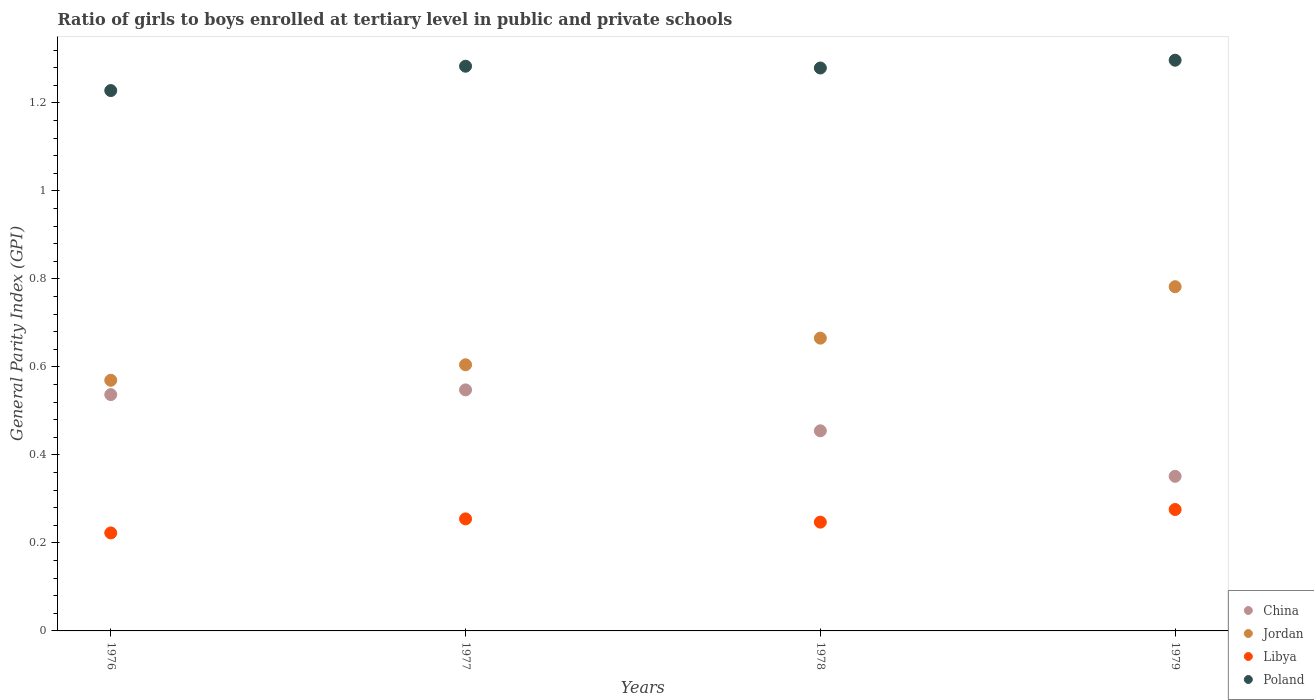How many different coloured dotlines are there?
Your response must be concise. 4. Is the number of dotlines equal to the number of legend labels?
Provide a short and direct response. Yes. What is the general parity index in China in 1977?
Keep it short and to the point. 0.55. Across all years, what is the maximum general parity index in Jordan?
Offer a terse response. 0.78. Across all years, what is the minimum general parity index in China?
Provide a succinct answer. 0.35. In which year was the general parity index in Poland minimum?
Make the answer very short. 1976. What is the total general parity index in China in the graph?
Give a very brief answer. 1.89. What is the difference between the general parity index in Libya in 1976 and that in 1977?
Keep it short and to the point. -0.03. What is the difference between the general parity index in Poland in 1979 and the general parity index in China in 1978?
Make the answer very short. 0.84. What is the average general parity index in Poland per year?
Offer a terse response. 1.27. In the year 1979, what is the difference between the general parity index in Poland and general parity index in Jordan?
Provide a succinct answer. 0.51. In how many years, is the general parity index in Poland greater than 0.12?
Ensure brevity in your answer.  4. What is the ratio of the general parity index in Libya in 1976 to that in 1977?
Make the answer very short. 0.87. Is the difference between the general parity index in Poland in 1977 and 1978 greater than the difference between the general parity index in Jordan in 1977 and 1978?
Offer a very short reply. Yes. What is the difference between the highest and the second highest general parity index in Poland?
Keep it short and to the point. 0.01. What is the difference between the highest and the lowest general parity index in Poland?
Provide a succinct answer. 0.07. Is the sum of the general parity index in Poland in 1977 and 1978 greater than the maximum general parity index in China across all years?
Your answer should be compact. Yes. Is it the case that in every year, the sum of the general parity index in Libya and general parity index in Jordan  is greater than the sum of general parity index in China and general parity index in Poland?
Ensure brevity in your answer.  No. Is the general parity index in China strictly less than the general parity index in Libya over the years?
Offer a very short reply. No. How many dotlines are there?
Provide a succinct answer. 4. Are the values on the major ticks of Y-axis written in scientific E-notation?
Provide a succinct answer. No. Does the graph contain grids?
Keep it short and to the point. No. Where does the legend appear in the graph?
Offer a very short reply. Bottom right. How are the legend labels stacked?
Make the answer very short. Vertical. What is the title of the graph?
Provide a short and direct response. Ratio of girls to boys enrolled at tertiary level in public and private schools. What is the label or title of the Y-axis?
Provide a succinct answer. General Parity Index (GPI). What is the General Parity Index (GPI) of China in 1976?
Provide a short and direct response. 0.54. What is the General Parity Index (GPI) in Jordan in 1976?
Offer a very short reply. 0.57. What is the General Parity Index (GPI) of Libya in 1976?
Offer a very short reply. 0.22. What is the General Parity Index (GPI) of Poland in 1976?
Give a very brief answer. 1.23. What is the General Parity Index (GPI) in China in 1977?
Make the answer very short. 0.55. What is the General Parity Index (GPI) in Jordan in 1977?
Offer a terse response. 0.6. What is the General Parity Index (GPI) in Libya in 1977?
Your answer should be compact. 0.25. What is the General Parity Index (GPI) of Poland in 1977?
Ensure brevity in your answer.  1.28. What is the General Parity Index (GPI) of China in 1978?
Make the answer very short. 0.45. What is the General Parity Index (GPI) of Jordan in 1978?
Offer a very short reply. 0.67. What is the General Parity Index (GPI) of Libya in 1978?
Provide a succinct answer. 0.25. What is the General Parity Index (GPI) of Poland in 1978?
Make the answer very short. 1.28. What is the General Parity Index (GPI) in China in 1979?
Your answer should be very brief. 0.35. What is the General Parity Index (GPI) of Jordan in 1979?
Provide a succinct answer. 0.78. What is the General Parity Index (GPI) in Libya in 1979?
Your answer should be compact. 0.28. What is the General Parity Index (GPI) in Poland in 1979?
Your response must be concise. 1.3. Across all years, what is the maximum General Parity Index (GPI) in China?
Your answer should be very brief. 0.55. Across all years, what is the maximum General Parity Index (GPI) in Jordan?
Give a very brief answer. 0.78. Across all years, what is the maximum General Parity Index (GPI) of Libya?
Provide a succinct answer. 0.28. Across all years, what is the maximum General Parity Index (GPI) of Poland?
Offer a terse response. 1.3. Across all years, what is the minimum General Parity Index (GPI) in China?
Make the answer very short. 0.35. Across all years, what is the minimum General Parity Index (GPI) in Jordan?
Give a very brief answer. 0.57. Across all years, what is the minimum General Parity Index (GPI) of Libya?
Provide a succinct answer. 0.22. Across all years, what is the minimum General Parity Index (GPI) of Poland?
Provide a short and direct response. 1.23. What is the total General Parity Index (GPI) in China in the graph?
Provide a short and direct response. 1.89. What is the total General Parity Index (GPI) in Jordan in the graph?
Keep it short and to the point. 2.62. What is the total General Parity Index (GPI) in Libya in the graph?
Offer a terse response. 1. What is the total General Parity Index (GPI) of Poland in the graph?
Provide a succinct answer. 5.09. What is the difference between the General Parity Index (GPI) of China in 1976 and that in 1977?
Your answer should be compact. -0.01. What is the difference between the General Parity Index (GPI) in Jordan in 1976 and that in 1977?
Give a very brief answer. -0.04. What is the difference between the General Parity Index (GPI) in Libya in 1976 and that in 1977?
Offer a terse response. -0.03. What is the difference between the General Parity Index (GPI) of Poland in 1976 and that in 1977?
Give a very brief answer. -0.06. What is the difference between the General Parity Index (GPI) in China in 1976 and that in 1978?
Offer a very short reply. 0.08. What is the difference between the General Parity Index (GPI) of Jordan in 1976 and that in 1978?
Offer a very short reply. -0.1. What is the difference between the General Parity Index (GPI) in Libya in 1976 and that in 1978?
Your response must be concise. -0.02. What is the difference between the General Parity Index (GPI) of Poland in 1976 and that in 1978?
Your response must be concise. -0.05. What is the difference between the General Parity Index (GPI) of China in 1976 and that in 1979?
Make the answer very short. 0.19. What is the difference between the General Parity Index (GPI) of Jordan in 1976 and that in 1979?
Provide a short and direct response. -0.21. What is the difference between the General Parity Index (GPI) of Libya in 1976 and that in 1979?
Give a very brief answer. -0.05. What is the difference between the General Parity Index (GPI) of Poland in 1976 and that in 1979?
Offer a terse response. -0.07. What is the difference between the General Parity Index (GPI) of China in 1977 and that in 1978?
Your answer should be compact. 0.09. What is the difference between the General Parity Index (GPI) in Jordan in 1977 and that in 1978?
Your response must be concise. -0.06. What is the difference between the General Parity Index (GPI) in Libya in 1977 and that in 1978?
Give a very brief answer. 0.01. What is the difference between the General Parity Index (GPI) in Poland in 1977 and that in 1978?
Keep it short and to the point. 0. What is the difference between the General Parity Index (GPI) in China in 1977 and that in 1979?
Provide a succinct answer. 0.2. What is the difference between the General Parity Index (GPI) of Jordan in 1977 and that in 1979?
Provide a short and direct response. -0.18. What is the difference between the General Parity Index (GPI) of Libya in 1977 and that in 1979?
Offer a terse response. -0.02. What is the difference between the General Parity Index (GPI) of Poland in 1977 and that in 1979?
Offer a terse response. -0.01. What is the difference between the General Parity Index (GPI) in China in 1978 and that in 1979?
Offer a very short reply. 0.1. What is the difference between the General Parity Index (GPI) in Jordan in 1978 and that in 1979?
Ensure brevity in your answer.  -0.12. What is the difference between the General Parity Index (GPI) in Libya in 1978 and that in 1979?
Provide a succinct answer. -0.03. What is the difference between the General Parity Index (GPI) of Poland in 1978 and that in 1979?
Keep it short and to the point. -0.02. What is the difference between the General Parity Index (GPI) of China in 1976 and the General Parity Index (GPI) of Jordan in 1977?
Your response must be concise. -0.07. What is the difference between the General Parity Index (GPI) of China in 1976 and the General Parity Index (GPI) of Libya in 1977?
Your answer should be compact. 0.28. What is the difference between the General Parity Index (GPI) in China in 1976 and the General Parity Index (GPI) in Poland in 1977?
Your answer should be compact. -0.75. What is the difference between the General Parity Index (GPI) of Jordan in 1976 and the General Parity Index (GPI) of Libya in 1977?
Provide a succinct answer. 0.32. What is the difference between the General Parity Index (GPI) in Jordan in 1976 and the General Parity Index (GPI) in Poland in 1977?
Your answer should be compact. -0.71. What is the difference between the General Parity Index (GPI) in Libya in 1976 and the General Parity Index (GPI) in Poland in 1977?
Offer a terse response. -1.06. What is the difference between the General Parity Index (GPI) of China in 1976 and the General Parity Index (GPI) of Jordan in 1978?
Give a very brief answer. -0.13. What is the difference between the General Parity Index (GPI) in China in 1976 and the General Parity Index (GPI) in Libya in 1978?
Offer a very short reply. 0.29. What is the difference between the General Parity Index (GPI) in China in 1976 and the General Parity Index (GPI) in Poland in 1978?
Give a very brief answer. -0.74. What is the difference between the General Parity Index (GPI) of Jordan in 1976 and the General Parity Index (GPI) of Libya in 1978?
Offer a very short reply. 0.32. What is the difference between the General Parity Index (GPI) in Jordan in 1976 and the General Parity Index (GPI) in Poland in 1978?
Provide a short and direct response. -0.71. What is the difference between the General Parity Index (GPI) in Libya in 1976 and the General Parity Index (GPI) in Poland in 1978?
Your answer should be compact. -1.06. What is the difference between the General Parity Index (GPI) in China in 1976 and the General Parity Index (GPI) in Jordan in 1979?
Your answer should be compact. -0.25. What is the difference between the General Parity Index (GPI) in China in 1976 and the General Parity Index (GPI) in Libya in 1979?
Make the answer very short. 0.26. What is the difference between the General Parity Index (GPI) in China in 1976 and the General Parity Index (GPI) in Poland in 1979?
Offer a terse response. -0.76. What is the difference between the General Parity Index (GPI) of Jordan in 1976 and the General Parity Index (GPI) of Libya in 1979?
Your response must be concise. 0.29. What is the difference between the General Parity Index (GPI) in Jordan in 1976 and the General Parity Index (GPI) in Poland in 1979?
Offer a terse response. -0.73. What is the difference between the General Parity Index (GPI) of Libya in 1976 and the General Parity Index (GPI) of Poland in 1979?
Offer a terse response. -1.07. What is the difference between the General Parity Index (GPI) in China in 1977 and the General Parity Index (GPI) in Jordan in 1978?
Give a very brief answer. -0.12. What is the difference between the General Parity Index (GPI) of China in 1977 and the General Parity Index (GPI) of Libya in 1978?
Give a very brief answer. 0.3. What is the difference between the General Parity Index (GPI) in China in 1977 and the General Parity Index (GPI) in Poland in 1978?
Make the answer very short. -0.73. What is the difference between the General Parity Index (GPI) in Jordan in 1977 and the General Parity Index (GPI) in Libya in 1978?
Your response must be concise. 0.36. What is the difference between the General Parity Index (GPI) in Jordan in 1977 and the General Parity Index (GPI) in Poland in 1978?
Provide a succinct answer. -0.67. What is the difference between the General Parity Index (GPI) in Libya in 1977 and the General Parity Index (GPI) in Poland in 1978?
Provide a succinct answer. -1.02. What is the difference between the General Parity Index (GPI) of China in 1977 and the General Parity Index (GPI) of Jordan in 1979?
Give a very brief answer. -0.23. What is the difference between the General Parity Index (GPI) in China in 1977 and the General Parity Index (GPI) in Libya in 1979?
Offer a very short reply. 0.27. What is the difference between the General Parity Index (GPI) in China in 1977 and the General Parity Index (GPI) in Poland in 1979?
Offer a very short reply. -0.75. What is the difference between the General Parity Index (GPI) of Jordan in 1977 and the General Parity Index (GPI) of Libya in 1979?
Your response must be concise. 0.33. What is the difference between the General Parity Index (GPI) of Jordan in 1977 and the General Parity Index (GPI) of Poland in 1979?
Offer a very short reply. -0.69. What is the difference between the General Parity Index (GPI) in Libya in 1977 and the General Parity Index (GPI) in Poland in 1979?
Your answer should be compact. -1.04. What is the difference between the General Parity Index (GPI) of China in 1978 and the General Parity Index (GPI) of Jordan in 1979?
Ensure brevity in your answer.  -0.33. What is the difference between the General Parity Index (GPI) of China in 1978 and the General Parity Index (GPI) of Libya in 1979?
Provide a succinct answer. 0.18. What is the difference between the General Parity Index (GPI) of China in 1978 and the General Parity Index (GPI) of Poland in 1979?
Your response must be concise. -0.84. What is the difference between the General Parity Index (GPI) of Jordan in 1978 and the General Parity Index (GPI) of Libya in 1979?
Ensure brevity in your answer.  0.39. What is the difference between the General Parity Index (GPI) of Jordan in 1978 and the General Parity Index (GPI) of Poland in 1979?
Provide a succinct answer. -0.63. What is the difference between the General Parity Index (GPI) of Libya in 1978 and the General Parity Index (GPI) of Poland in 1979?
Ensure brevity in your answer.  -1.05. What is the average General Parity Index (GPI) in China per year?
Provide a short and direct response. 0.47. What is the average General Parity Index (GPI) of Jordan per year?
Offer a very short reply. 0.66. What is the average General Parity Index (GPI) in Libya per year?
Offer a terse response. 0.25. What is the average General Parity Index (GPI) in Poland per year?
Give a very brief answer. 1.27. In the year 1976, what is the difference between the General Parity Index (GPI) of China and General Parity Index (GPI) of Jordan?
Offer a very short reply. -0.03. In the year 1976, what is the difference between the General Parity Index (GPI) of China and General Parity Index (GPI) of Libya?
Keep it short and to the point. 0.31. In the year 1976, what is the difference between the General Parity Index (GPI) of China and General Parity Index (GPI) of Poland?
Your answer should be very brief. -0.69. In the year 1976, what is the difference between the General Parity Index (GPI) of Jordan and General Parity Index (GPI) of Libya?
Ensure brevity in your answer.  0.35. In the year 1976, what is the difference between the General Parity Index (GPI) of Jordan and General Parity Index (GPI) of Poland?
Provide a short and direct response. -0.66. In the year 1976, what is the difference between the General Parity Index (GPI) of Libya and General Parity Index (GPI) of Poland?
Provide a short and direct response. -1.01. In the year 1977, what is the difference between the General Parity Index (GPI) of China and General Parity Index (GPI) of Jordan?
Offer a terse response. -0.06. In the year 1977, what is the difference between the General Parity Index (GPI) in China and General Parity Index (GPI) in Libya?
Your response must be concise. 0.29. In the year 1977, what is the difference between the General Parity Index (GPI) of China and General Parity Index (GPI) of Poland?
Your answer should be very brief. -0.74. In the year 1977, what is the difference between the General Parity Index (GPI) of Jordan and General Parity Index (GPI) of Libya?
Offer a very short reply. 0.35. In the year 1977, what is the difference between the General Parity Index (GPI) in Jordan and General Parity Index (GPI) in Poland?
Your answer should be very brief. -0.68. In the year 1977, what is the difference between the General Parity Index (GPI) of Libya and General Parity Index (GPI) of Poland?
Your answer should be very brief. -1.03. In the year 1978, what is the difference between the General Parity Index (GPI) in China and General Parity Index (GPI) in Jordan?
Ensure brevity in your answer.  -0.21. In the year 1978, what is the difference between the General Parity Index (GPI) of China and General Parity Index (GPI) of Libya?
Your answer should be very brief. 0.21. In the year 1978, what is the difference between the General Parity Index (GPI) in China and General Parity Index (GPI) in Poland?
Your answer should be compact. -0.82. In the year 1978, what is the difference between the General Parity Index (GPI) in Jordan and General Parity Index (GPI) in Libya?
Your answer should be compact. 0.42. In the year 1978, what is the difference between the General Parity Index (GPI) of Jordan and General Parity Index (GPI) of Poland?
Give a very brief answer. -0.61. In the year 1978, what is the difference between the General Parity Index (GPI) in Libya and General Parity Index (GPI) in Poland?
Provide a succinct answer. -1.03. In the year 1979, what is the difference between the General Parity Index (GPI) of China and General Parity Index (GPI) of Jordan?
Give a very brief answer. -0.43. In the year 1979, what is the difference between the General Parity Index (GPI) in China and General Parity Index (GPI) in Libya?
Keep it short and to the point. 0.08. In the year 1979, what is the difference between the General Parity Index (GPI) in China and General Parity Index (GPI) in Poland?
Provide a short and direct response. -0.95. In the year 1979, what is the difference between the General Parity Index (GPI) in Jordan and General Parity Index (GPI) in Libya?
Give a very brief answer. 0.51. In the year 1979, what is the difference between the General Parity Index (GPI) of Jordan and General Parity Index (GPI) of Poland?
Offer a terse response. -0.51. In the year 1979, what is the difference between the General Parity Index (GPI) of Libya and General Parity Index (GPI) of Poland?
Provide a succinct answer. -1.02. What is the ratio of the General Parity Index (GPI) of China in 1976 to that in 1977?
Provide a succinct answer. 0.98. What is the ratio of the General Parity Index (GPI) in Jordan in 1976 to that in 1977?
Your answer should be very brief. 0.94. What is the ratio of the General Parity Index (GPI) of Libya in 1976 to that in 1977?
Your response must be concise. 0.87. What is the ratio of the General Parity Index (GPI) of Poland in 1976 to that in 1977?
Keep it short and to the point. 0.96. What is the ratio of the General Parity Index (GPI) of China in 1976 to that in 1978?
Your response must be concise. 1.18. What is the ratio of the General Parity Index (GPI) in Jordan in 1976 to that in 1978?
Make the answer very short. 0.86. What is the ratio of the General Parity Index (GPI) in Libya in 1976 to that in 1978?
Offer a very short reply. 0.9. What is the ratio of the General Parity Index (GPI) in Poland in 1976 to that in 1978?
Offer a terse response. 0.96. What is the ratio of the General Parity Index (GPI) in China in 1976 to that in 1979?
Provide a succinct answer. 1.53. What is the ratio of the General Parity Index (GPI) of Jordan in 1976 to that in 1979?
Offer a very short reply. 0.73. What is the ratio of the General Parity Index (GPI) of Libya in 1976 to that in 1979?
Offer a terse response. 0.81. What is the ratio of the General Parity Index (GPI) of Poland in 1976 to that in 1979?
Offer a very short reply. 0.95. What is the ratio of the General Parity Index (GPI) of China in 1977 to that in 1978?
Ensure brevity in your answer.  1.2. What is the ratio of the General Parity Index (GPI) in Jordan in 1977 to that in 1978?
Ensure brevity in your answer.  0.91. What is the ratio of the General Parity Index (GPI) in Poland in 1977 to that in 1978?
Your answer should be compact. 1. What is the ratio of the General Parity Index (GPI) of China in 1977 to that in 1979?
Ensure brevity in your answer.  1.56. What is the ratio of the General Parity Index (GPI) in Jordan in 1977 to that in 1979?
Make the answer very short. 0.77. What is the ratio of the General Parity Index (GPI) of Libya in 1977 to that in 1979?
Your answer should be compact. 0.92. What is the ratio of the General Parity Index (GPI) of Poland in 1977 to that in 1979?
Your answer should be compact. 0.99. What is the ratio of the General Parity Index (GPI) in China in 1978 to that in 1979?
Provide a succinct answer. 1.29. What is the ratio of the General Parity Index (GPI) in Jordan in 1978 to that in 1979?
Your answer should be compact. 0.85. What is the ratio of the General Parity Index (GPI) in Libya in 1978 to that in 1979?
Make the answer very short. 0.9. What is the ratio of the General Parity Index (GPI) in Poland in 1978 to that in 1979?
Give a very brief answer. 0.99. What is the difference between the highest and the second highest General Parity Index (GPI) of China?
Give a very brief answer. 0.01. What is the difference between the highest and the second highest General Parity Index (GPI) of Jordan?
Keep it short and to the point. 0.12. What is the difference between the highest and the second highest General Parity Index (GPI) in Libya?
Your response must be concise. 0.02. What is the difference between the highest and the second highest General Parity Index (GPI) in Poland?
Provide a short and direct response. 0.01. What is the difference between the highest and the lowest General Parity Index (GPI) of China?
Ensure brevity in your answer.  0.2. What is the difference between the highest and the lowest General Parity Index (GPI) of Jordan?
Offer a terse response. 0.21. What is the difference between the highest and the lowest General Parity Index (GPI) of Libya?
Ensure brevity in your answer.  0.05. What is the difference between the highest and the lowest General Parity Index (GPI) of Poland?
Ensure brevity in your answer.  0.07. 